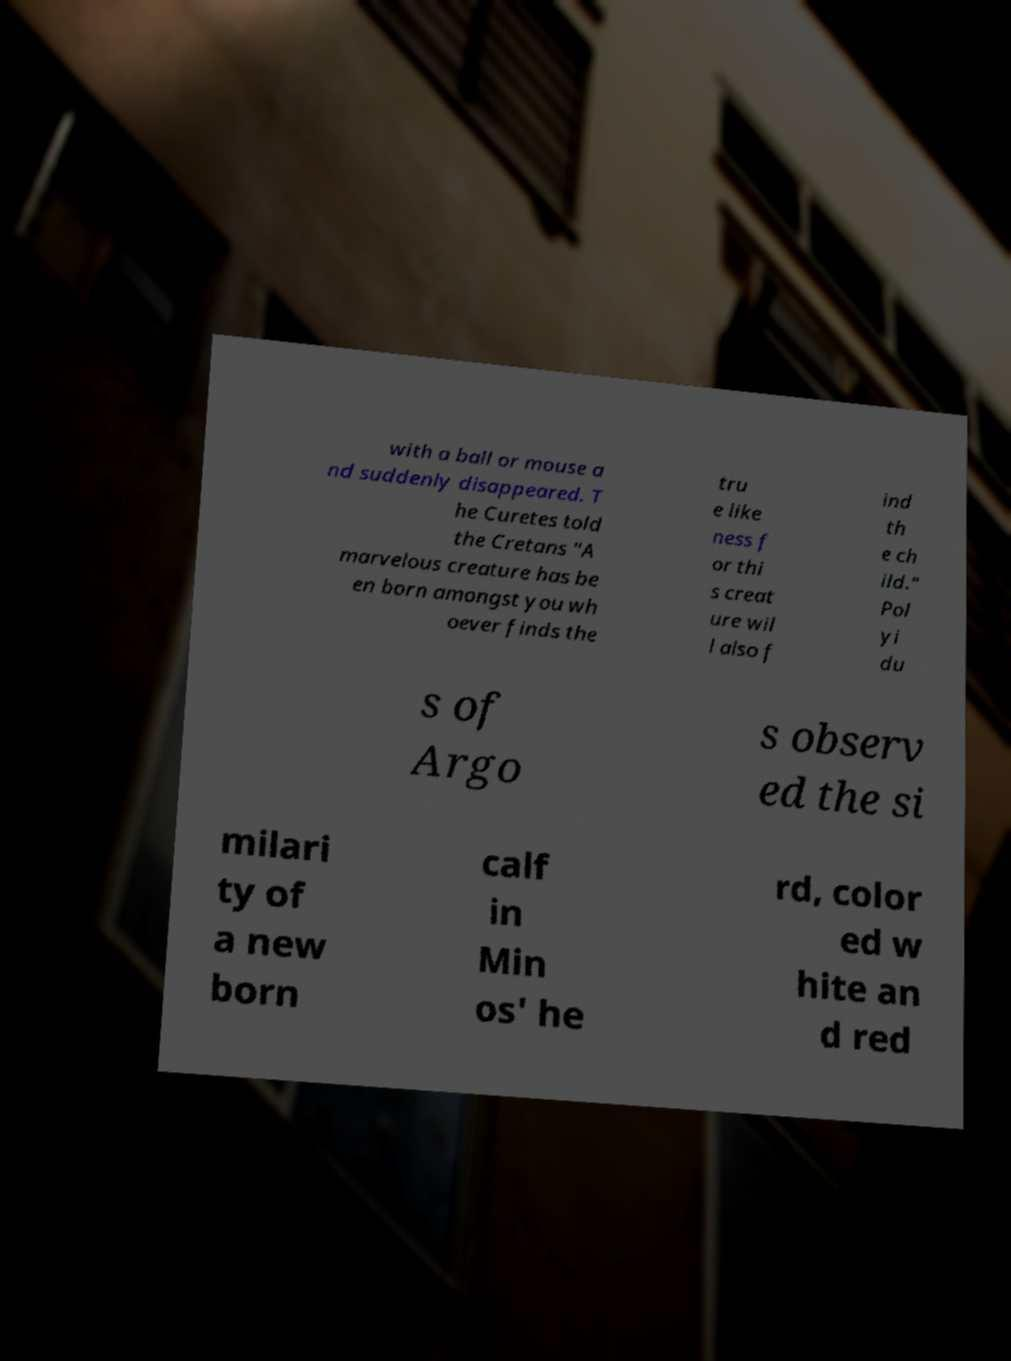There's text embedded in this image that I need extracted. Can you transcribe it verbatim? with a ball or mouse a nd suddenly disappeared. T he Curetes told the Cretans "A marvelous creature has be en born amongst you wh oever finds the tru e like ness f or thi s creat ure wil l also f ind th e ch ild." Pol yi du s of Argo s observ ed the si milari ty of a new born calf in Min os' he rd, color ed w hite an d red 